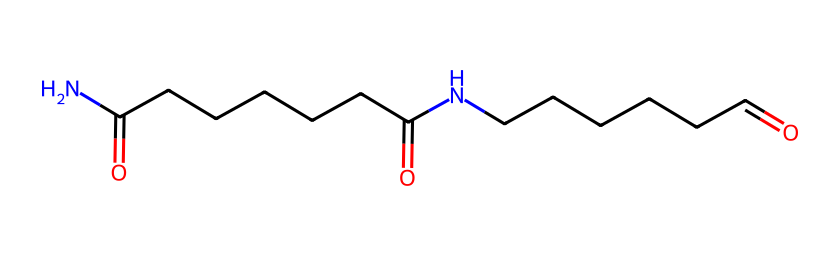What is the main functional group present in the chemical structure? The structure contains amide linkages, identified by the nitrogen atom bonded to carbonyl groups, which are typical of amides.
Answer: amide How many carbon atoms are in the backbone of this chemical? Counting the carbon atoms along the main carbon chain, there are 12 carbon atoms in total.
Answer: 12 What is the total number of nitrogen atoms in the structure? There are two nitrogen atoms present in the molecule, each bonded to a carbonyl group forming the amide structures.
Answer: 2 How many oxygen atoms are present in the chemical? Analyzing the structure, there are four oxygen atoms that are part of the two carbonyl functional groups attached to the nitrogen atoms.
Answer: 4 What type of polymer does this chemical represent? This chemical is representative of a synthetic polyamide, specifically nylon-6,6, due to its characteristic repeating amide linkages.
Answer: polyamide What property does the presence of nitrogen in the backbone impart to the textile made from this chemical? The nitrogen in the amide bonds increases the strength of the textile fibers, contributing to its durability and resilience.
Answer: strength 